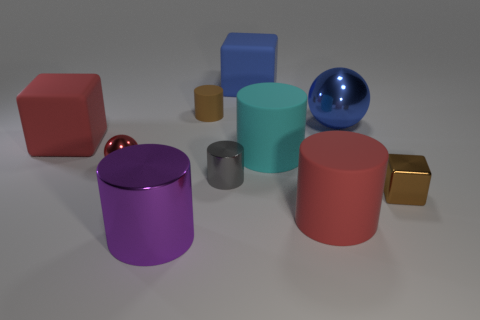Subtract all brown cylinders. How many cylinders are left? 4 Subtract all big red matte cylinders. How many cylinders are left? 4 Subtract all blue cylinders. Subtract all purple blocks. How many cylinders are left? 5 Subtract all spheres. How many objects are left? 8 Subtract 1 brown cylinders. How many objects are left? 9 Subtract all large red cubes. Subtract all large metal balls. How many objects are left? 8 Add 8 big blue matte blocks. How many big blue matte blocks are left? 9 Add 7 small brown matte cylinders. How many small brown matte cylinders exist? 8 